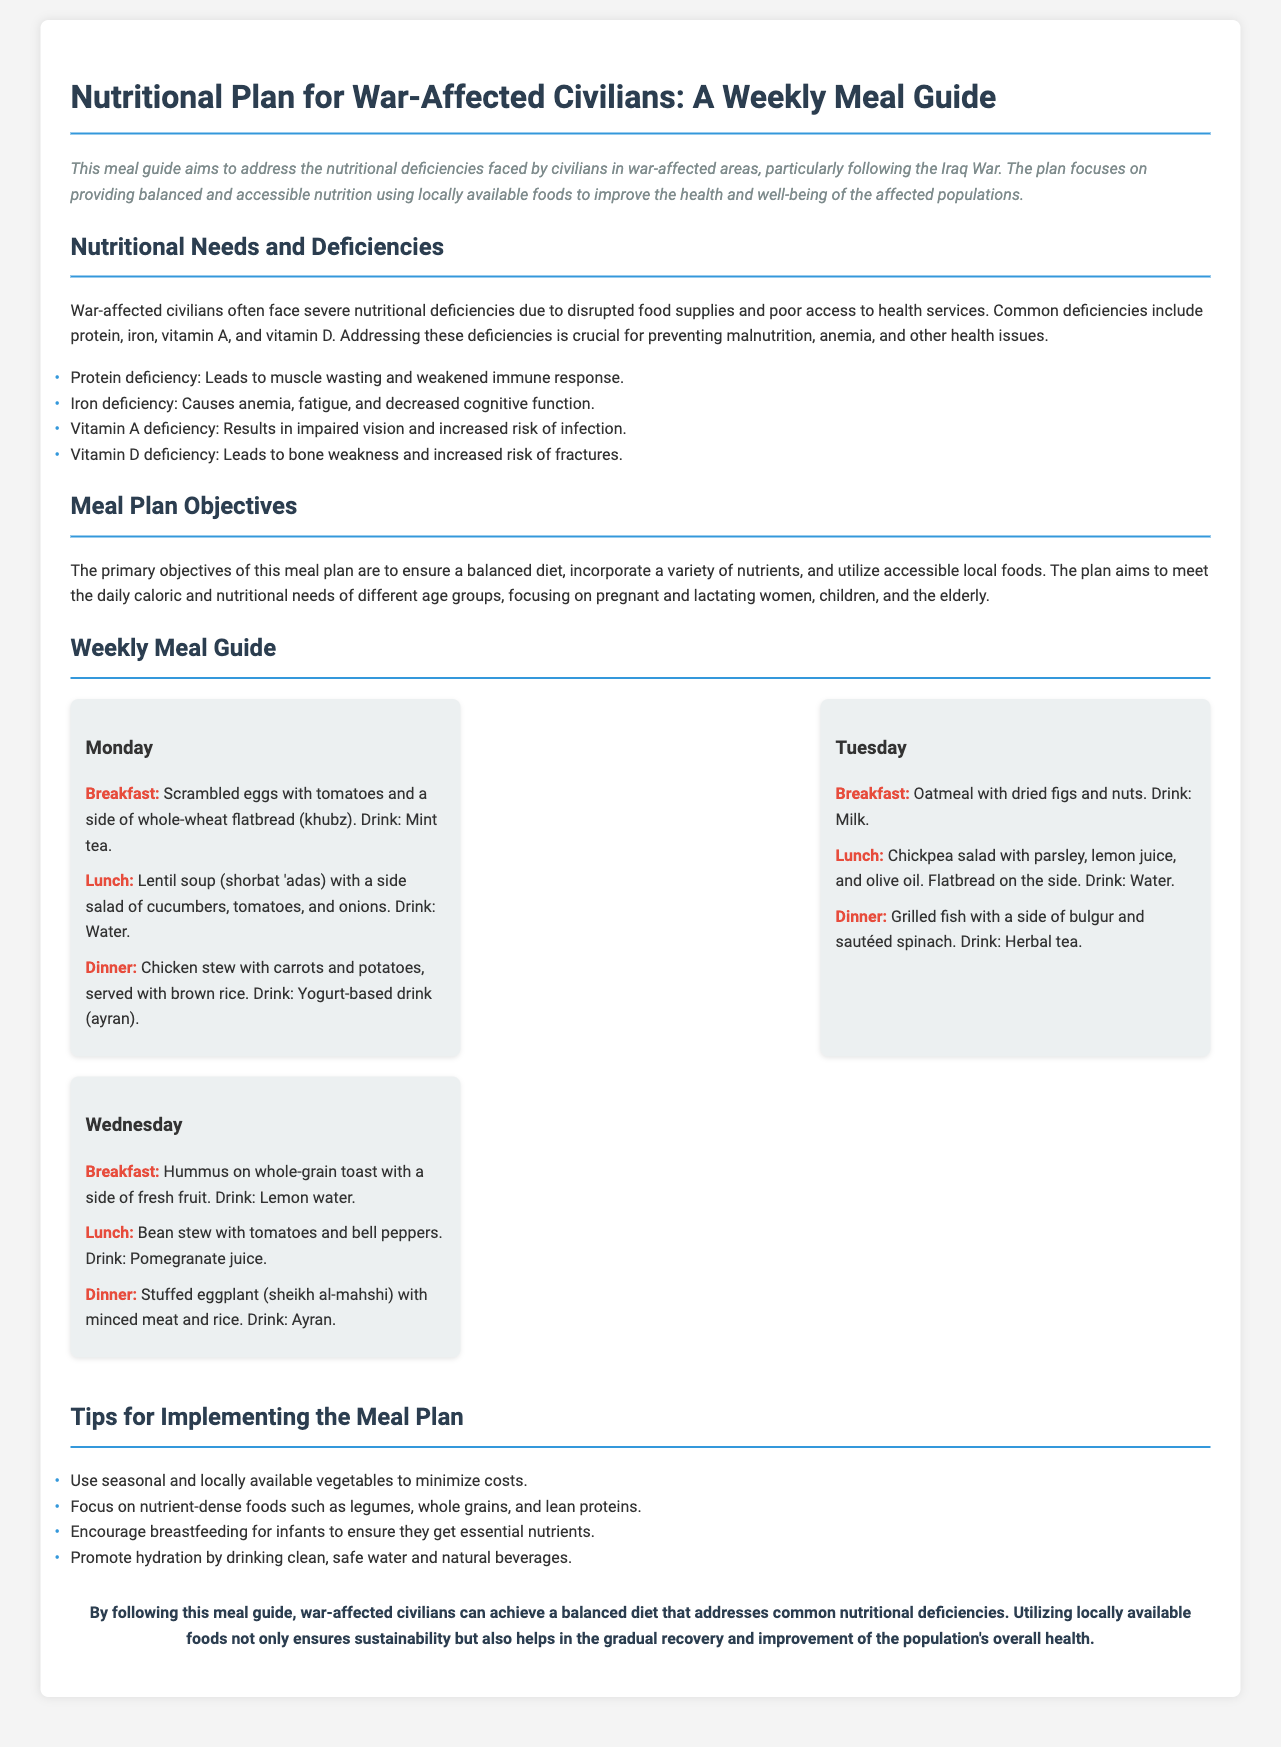What is the title of the document? The title is stated clearly at the top of the document.
Answer: Nutritional Plan for War-Affected Civilians: A Weekly Meal Guide What are the common nutritional deficiencies mentioned? The document lists specific deficiencies affecting civilians due to war.
Answer: Protein, iron, vitamin A, vitamin D What drink is served with the dinner on Monday? The document specifies the drink served with each meal, including Monday's dinner.
Answer: Yogurt-based drink (ayran) On which day is oatmeal for breakfast? The document provides a detailed meal plan, indicating breakfast items for each day.
Answer: Tuesday What type of soup is included in Monday's lunch? This query seeks to identify the specific soup mentioned for lunch on Monday.
Answer: Lentil soup (shorbat 'adas) What is one of the objectives of the meal plan? The document describes the primary objectives guiding the nutritional guide.
Answer: Ensure a balanced diet How many meals are listed for each day? The meal structure in the document outlines the number of meals provided.
Answer: Three Which vegetable is used in the stuffed dish on Wednesday? The document details the main ingredients of the meals, including Wednesday's dinner.
Answer: Eggplant What type of salad is served on Tuesday’s lunch? The meal plan specifies the type of salad included in Tuesday's lunch.
Answer: Chickpea salad 